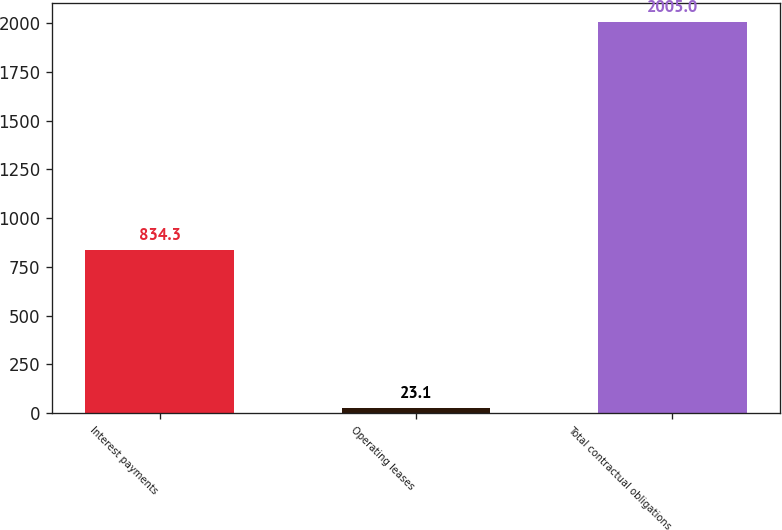Convert chart. <chart><loc_0><loc_0><loc_500><loc_500><bar_chart><fcel>Interest payments<fcel>Operating leases<fcel>Total contractual obligations<nl><fcel>834.3<fcel>23.1<fcel>2005<nl></chart> 